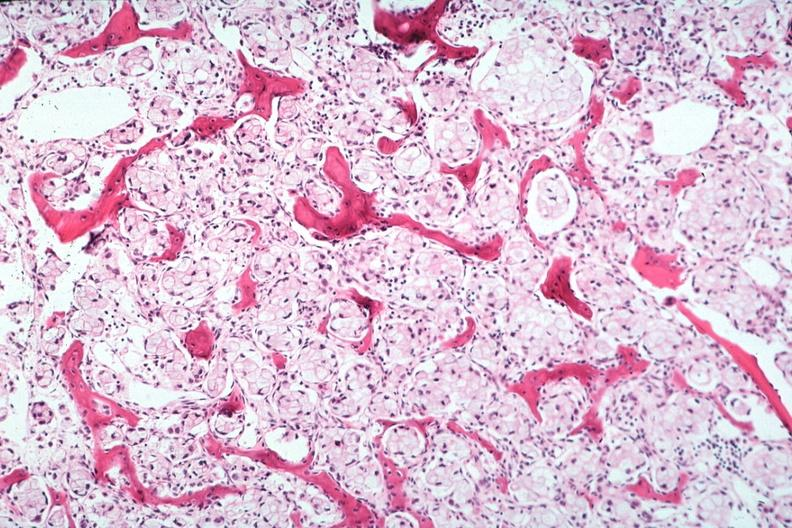what does this image show?
Answer the question using a single word or phrase. Stomach primary 